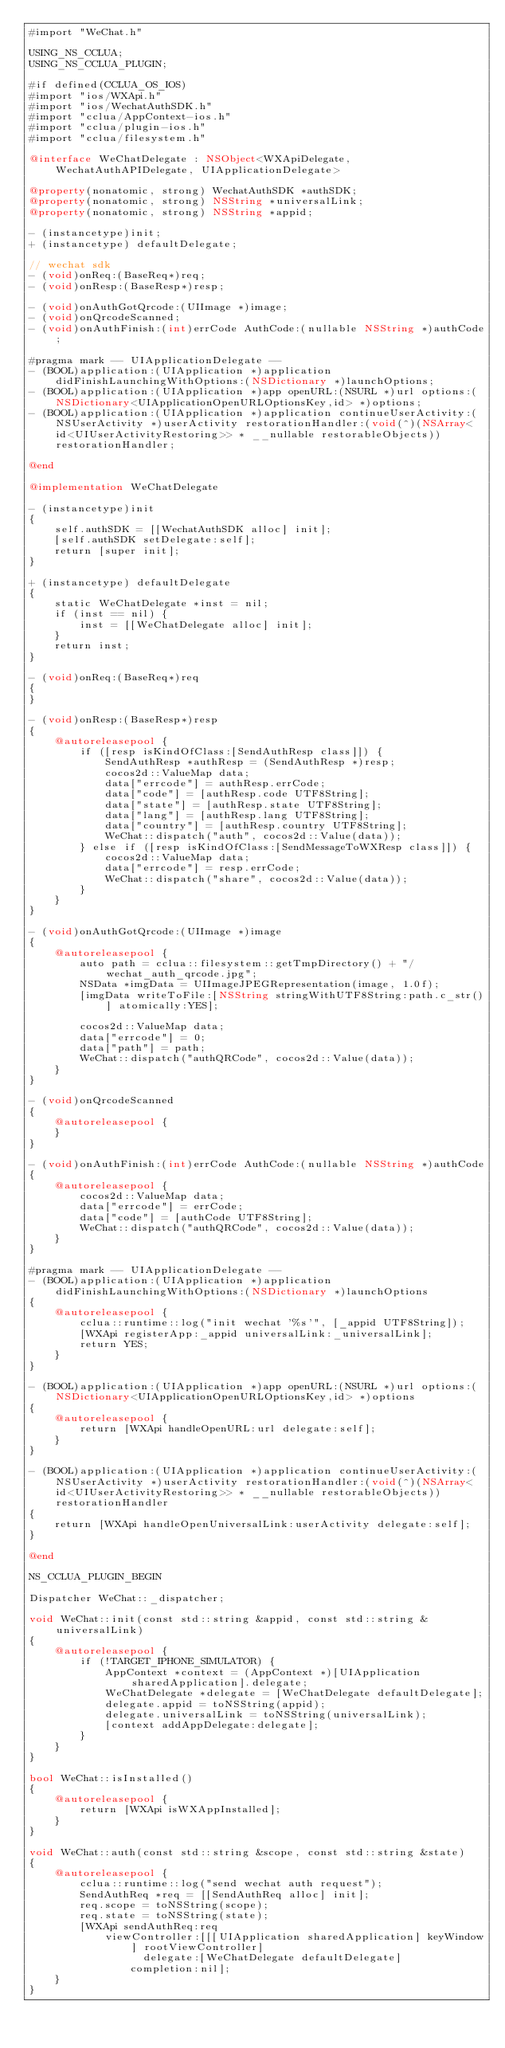Convert code to text. <code><loc_0><loc_0><loc_500><loc_500><_ObjectiveC_>#import "WeChat.h"

USING_NS_CCLUA;
USING_NS_CCLUA_PLUGIN;

#if defined(CCLUA_OS_IOS)
#import "ios/WXApi.h"
#import "ios/WechatAuthSDK.h"
#import "cclua/AppContext-ios.h"
#import "cclua/plugin-ios.h"
#import "cclua/filesystem.h"

@interface WeChatDelegate : NSObject<WXApiDelegate, WechatAuthAPIDelegate, UIApplicationDelegate>

@property(nonatomic, strong) WechatAuthSDK *authSDK;
@property(nonatomic, strong) NSString *universalLink;
@property(nonatomic, strong) NSString *appid;

- (instancetype)init;
+ (instancetype) defaultDelegate;

// wechat sdk
- (void)onReq:(BaseReq*)req;
- (void)onResp:(BaseResp*)resp;

- (void)onAuthGotQrcode:(UIImage *)image;
- (void)onQrcodeScanned;
- (void)onAuthFinish:(int)errCode AuthCode:(nullable NSString *)authCode;

#pragma mark -- UIApplicationDelegate --
- (BOOL)application:(UIApplication *)application didFinishLaunchingWithOptions:(NSDictionary *)launchOptions;
- (BOOL)application:(UIApplication *)app openURL:(NSURL *)url options:(NSDictionary<UIApplicationOpenURLOptionsKey,id> *)options;
- (BOOL)application:(UIApplication *)application continueUserActivity:(NSUserActivity *)userActivity restorationHandler:(void(^)(NSArray<id<UIUserActivityRestoring>> * __nullable restorableObjects))restorationHandler;

@end

@implementation WeChatDelegate

- (instancetype)init
{
    self.authSDK = [[WechatAuthSDK alloc] init];
    [self.authSDK setDelegate:self];
    return [super init];
}

+ (instancetype) defaultDelegate
{
    static WeChatDelegate *inst = nil;
    if (inst == nil) {
        inst = [[WeChatDelegate alloc] init];
    }
    return inst;
}

- (void)onReq:(BaseReq*)req
{
}

- (void)onResp:(BaseResp*)resp
{
    @autoreleasepool {
        if ([resp isKindOfClass:[SendAuthResp class]]) {
            SendAuthResp *authResp = (SendAuthResp *)resp;
            cocos2d::ValueMap data;
            data["errcode"] = authResp.errCode;
            data["code"] = [authResp.code UTF8String];
            data["state"] = [authResp.state UTF8String];
            data["lang"] = [authResp.lang UTF8String];
            data["country"] = [authResp.country UTF8String];
            WeChat::dispatch("auth", cocos2d::Value(data));
        } else if ([resp isKindOfClass:[SendMessageToWXResp class]]) {
            cocos2d::ValueMap data;
            data["errcode"] = resp.errCode;
            WeChat::dispatch("share", cocos2d::Value(data));
        }
    }
}

- (void)onAuthGotQrcode:(UIImage *)image
{
    @autoreleasepool {
        auto path = cclua::filesystem::getTmpDirectory() + "/wechat_auth_qrcode.jpg";
        NSData *imgData = UIImageJPEGRepresentation(image, 1.0f);
        [imgData writeToFile:[NSString stringWithUTF8String:path.c_str()] atomically:YES];
        
        cocos2d::ValueMap data;
        data["errcode"] = 0;
        data["path"] = path;
        WeChat::dispatch("authQRCode", cocos2d::Value(data));
    }
}

- (void)onQrcodeScanned
{
    @autoreleasepool {
    }
}

- (void)onAuthFinish:(int)errCode AuthCode:(nullable NSString *)authCode
{
    @autoreleasepool {
        cocos2d::ValueMap data;
        data["errcode"] = errCode;
        data["code"] = [authCode UTF8String];
        WeChat::dispatch("authQRCode", cocos2d::Value(data));
    }
}

#pragma mark -- UIApplicationDelegate --
- (BOOL)application:(UIApplication *)application didFinishLaunchingWithOptions:(NSDictionary *)launchOptions
{
    @autoreleasepool {
        cclua::runtime::log("init wechat '%s'", [_appid UTF8String]);
        [WXApi registerApp:_appid universalLink:_universalLink];
        return YES;
    }
}

- (BOOL)application:(UIApplication *)app openURL:(NSURL *)url options:(NSDictionary<UIApplicationOpenURLOptionsKey,id> *)options
{
    @autoreleasepool {
        return [WXApi handleOpenURL:url delegate:self];
    }
}

- (BOOL)application:(UIApplication *)application continueUserActivity:(NSUserActivity *)userActivity restorationHandler:(void(^)(NSArray<id<UIUserActivityRestoring>> * __nullable restorableObjects))restorationHandler
{
    return [WXApi handleOpenUniversalLink:userActivity delegate:self];
}

@end

NS_CCLUA_PLUGIN_BEGIN

Dispatcher WeChat::_dispatcher;

void WeChat::init(const std::string &appid, const std::string &universalLink)
{
    @autoreleasepool {
        if (!TARGET_IPHONE_SIMULATOR) {
            AppContext *context = (AppContext *)[UIApplication sharedApplication].delegate;
            WeChatDelegate *delegate = [WeChatDelegate defaultDelegate];
            delegate.appid = toNSString(appid);
            delegate.universalLink = toNSString(universalLink);
            [context addAppDelegate:delegate];
        }
    }
}

bool WeChat::isInstalled()
{
    @autoreleasepool {
        return [WXApi isWXAppInstalled];
    }
}

void WeChat::auth(const std::string &scope, const std::string &state)
{
    @autoreleasepool {
        cclua::runtime::log("send wechat auth request");
        SendAuthReq *req = [[SendAuthReq alloc] init];
        req.scope = toNSString(scope);
        req.state = toNSString(state);
        [WXApi sendAuthReq:req
            viewController:[[[UIApplication sharedApplication] keyWindow] rootViewController]
                  delegate:[WeChatDelegate defaultDelegate]
                completion:nil];
    }
}
</code> 